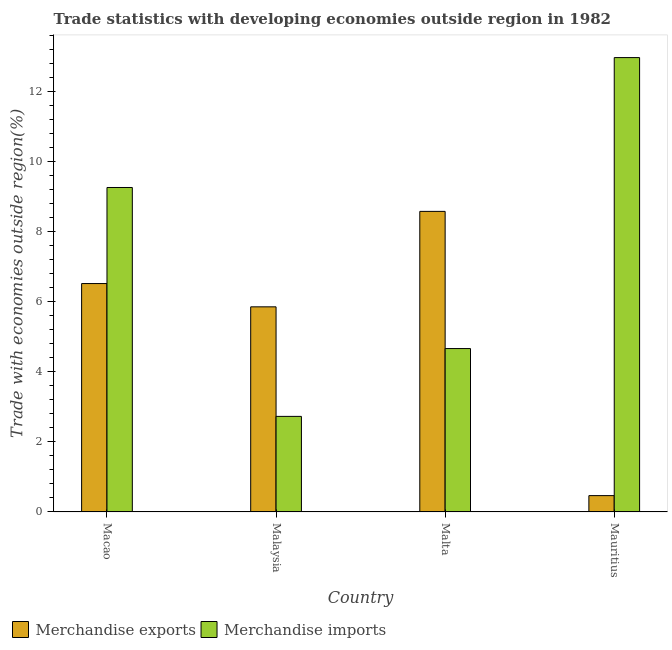Are the number of bars per tick equal to the number of legend labels?
Provide a short and direct response. Yes. Are the number of bars on each tick of the X-axis equal?
Provide a succinct answer. Yes. How many bars are there on the 1st tick from the left?
Provide a short and direct response. 2. What is the label of the 2nd group of bars from the left?
Keep it short and to the point. Malaysia. What is the merchandise exports in Malta?
Ensure brevity in your answer.  8.58. Across all countries, what is the maximum merchandise imports?
Your response must be concise. 12.97. Across all countries, what is the minimum merchandise exports?
Your answer should be compact. 0.47. In which country was the merchandise exports maximum?
Offer a terse response. Malta. In which country was the merchandise exports minimum?
Keep it short and to the point. Mauritius. What is the total merchandise exports in the graph?
Your response must be concise. 21.42. What is the difference between the merchandise imports in Malaysia and that in Mauritius?
Provide a succinct answer. -10.24. What is the difference between the merchandise imports in Macao and the merchandise exports in Malta?
Offer a terse response. 0.68. What is the average merchandise exports per country?
Provide a succinct answer. 5.35. What is the difference between the merchandise exports and merchandise imports in Macao?
Your answer should be very brief. -2.74. In how many countries, is the merchandise imports greater than 9.6 %?
Provide a short and direct response. 1. What is the ratio of the merchandise exports in Malta to that in Mauritius?
Your answer should be compact. 18.41. What is the difference between the highest and the second highest merchandise exports?
Your answer should be very brief. 2.06. What is the difference between the highest and the lowest merchandise exports?
Provide a succinct answer. 8.11. In how many countries, is the merchandise exports greater than the average merchandise exports taken over all countries?
Keep it short and to the point. 3. Is the sum of the merchandise exports in Macao and Malta greater than the maximum merchandise imports across all countries?
Offer a terse response. Yes. What does the 2nd bar from the left in Mauritius represents?
Give a very brief answer. Merchandise imports. Are all the bars in the graph horizontal?
Provide a succinct answer. No. What is the difference between two consecutive major ticks on the Y-axis?
Make the answer very short. 2. Does the graph contain grids?
Your answer should be very brief. No. How many legend labels are there?
Your answer should be very brief. 2. What is the title of the graph?
Your answer should be compact. Trade statistics with developing economies outside region in 1982. What is the label or title of the Y-axis?
Provide a succinct answer. Trade with economies outside region(%). What is the Trade with economies outside region(%) of Merchandise exports in Macao?
Ensure brevity in your answer.  6.52. What is the Trade with economies outside region(%) of Merchandise imports in Macao?
Provide a short and direct response. 9.26. What is the Trade with economies outside region(%) in Merchandise exports in Malaysia?
Make the answer very short. 5.85. What is the Trade with economies outside region(%) of Merchandise imports in Malaysia?
Offer a terse response. 2.73. What is the Trade with economies outside region(%) in Merchandise exports in Malta?
Give a very brief answer. 8.58. What is the Trade with economies outside region(%) of Merchandise imports in Malta?
Provide a succinct answer. 4.66. What is the Trade with economies outside region(%) of Merchandise exports in Mauritius?
Provide a succinct answer. 0.47. What is the Trade with economies outside region(%) in Merchandise imports in Mauritius?
Your answer should be very brief. 12.97. Across all countries, what is the maximum Trade with economies outside region(%) of Merchandise exports?
Offer a terse response. 8.58. Across all countries, what is the maximum Trade with economies outside region(%) in Merchandise imports?
Provide a short and direct response. 12.97. Across all countries, what is the minimum Trade with economies outside region(%) in Merchandise exports?
Your answer should be very brief. 0.47. Across all countries, what is the minimum Trade with economies outside region(%) in Merchandise imports?
Your response must be concise. 2.73. What is the total Trade with economies outside region(%) in Merchandise exports in the graph?
Give a very brief answer. 21.42. What is the total Trade with economies outside region(%) of Merchandise imports in the graph?
Provide a succinct answer. 29.62. What is the difference between the Trade with economies outside region(%) in Merchandise exports in Macao and that in Malaysia?
Your response must be concise. 0.66. What is the difference between the Trade with economies outside region(%) of Merchandise imports in Macao and that in Malaysia?
Your answer should be very brief. 6.53. What is the difference between the Trade with economies outside region(%) in Merchandise exports in Macao and that in Malta?
Keep it short and to the point. -2.06. What is the difference between the Trade with economies outside region(%) of Merchandise imports in Macao and that in Malta?
Provide a succinct answer. 4.6. What is the difference between the Trade with economies outside region(%) in Merchandise exports in Macao and that in Mauritius?
Keep it short and to the point. 6.05. What is the difference between the Trade with economies outside region(%) of Merchandise imports in Macao and that in Mauritius?
Provide a short and direct response. -3.71. What is the difference between the Trade with economies outside region(%) in Merchandise exports in Malaysia and that in Malta?
Provide a succinct answer. -2.72. What is the difference between the Trade with economies outside region(%) of Merchandise imports in Malaysia and that in Malta?
Give a very brief answer. -1.94. What is the difference between the Trade with economies outside region(%) in Merchandise exports in Malaysia and that in Mauritius?
Provide a short and direct response. 5.39. What is the difference between the Trade with economies outside region(%) in Merchandise imports in Malaysia and that in Mauritius?
Make the answer very short. -10.24. What is the difference between the Trade with economies outside region(%) in Merchandise exports in Malta and that in Mauritius?
Make the answer very short. 8.11. What is the difference between the Trade with economies outside region(%) in Merchandise imports in Malta and that in Mauritius?
Offer a very short reply. -8.3. What is the difference between the Trade with economies outside region(%) in Merchandise exports in Macao and the Trade with economies outside region(%) in Merchandise imports in Malaysia?
Make the answer very short. 3.79. What is the difference between the Trade with economies outside region(%) of Merchandise exports in Macao and the Trade with economies outside region(%) of Merchandise imports in Malta?
Offer a terse response. 1.86. What is the difference between the Trade with economies outside region(%) of Merchandise exports in Macao and the Trade with economies outside region(%) of Merchandise imports in Mauritius?
Give a very brief answer. -6.45. What is the difference between the Trade with economies outside region(%) in Merchandise exports in Malaysia and the Trade with economies outside region(%) in Merchandise imports in Malta?
Keep it short and to the point. 1.19. What is the difference between the Trade with economies outside region(%) in Merchandise exports in Malaysia and the Trade with economies outside region(%) in Merchandise imports in Mauritius?
Offer a very short reply. -7.11. What is the difference between the Trade with economies outside region(%) in Merchandise exports in Malta and the Trade with economies outside region(%) in Merchandise imports in Mauritius?
Offer a terse response. -4.39. What is the average Trade with economies outside region(%) in Merchandise exports per country?
Ensure brevity in your answer.  5.35. What is the average Trade with economies outside region(%) of Merchandise imports per country?
Offer a terse response. 7.4. What is the difference between the Trade with economies outside region(%) of Merchandise exports and Trade with economies outside region(%) of Merchandise imports in Macao?
Keep it short and to the point. -2.74. What is the difference between the Trade with economies outside region(%) of Merchandise exports and Trade with economies outside region(%) of Merchandise imports in Malaysia?
Keep it short and to the point. 3.13. What is the difference between the Trade with economies outside region(%) in Merchandise exports and Trade with economies outside region(%) in Merchandise imports in Malta?
Your answer should be very brief. 3.91. What is the difference between the Trade with economies outside region(%) of Merchandise exports and Trade with economies outside region(%) of Merchandise imports in Mauritius?
Provide a succinct answer. -12.5. What is the ratio of the Trade with economies outside region(%) of Merchandise exports in Macao to that in Malaysia?
Keep it short and to the point. 1.11. What is the ratio of the Trade with economies outside region(%) of Merchandise imports in Macao to that in Malaysia?
Make the answer very short. 3.4. What is the ratio of the Trade with economies outside region(%) of Merchandise exports in Macao to that in Malta?
Your answer should be very brief. 0.76. What is the ratio of the Trade with economies outside region(%) in Merchandise imports in Macao to that in Malta?
Offer a terse response. 1.99. What is the ratio of the Trade with economies outside region(%) in Merchandise exports in Macao to that in Mauritius?
Keep it short and to the point. 13.99. What is the ratio of the Trade with economies outside region(%) in Merchandise imports in Macao to that in Mauritius?
Your response must be concise. 0.71. What is the ratio of the Trade with economies outside region(%) of Merchandise exports in Malaysia to that in Malta?
Keep it short and to the point. 0.68. What is the ratio of the Trade with economies outside region(%) of Merchandise imports in Malaysia to that in Malta?
Provide a succinct answer. 0.58. What is the ratio of the Trade with economies outside region(%) in Merchandise exports in Malaysia to that in Mauritius?
Provide a succinct answer. 12.57. What is the ratio of the Trade with economies outside region(%) of Merchandise imports in Malaysia to that in Mauritius?
Offer a very short reply. 0.21. What is the ratio of the Trade with economies outside region(%) in Merchandise exports in Malta to that in Mauritius?
Your response must be concise. 18.41. What is the ratio of the Trade with economies outside region(%) of Merchandise imports in Malta to that in Mauritius?
Ensure brevity in your answer.  0.36. What is the difference between the highest and the second highest Trade with economies outside region(%) in Merchandise exports?
Your answer should be compact. 2.06. What is the difference between the highest and the second highest Trade with economies outside region(%) in Merchandise imports?
Give a very brief answer. 3.71. What is the difference between the highest and the lowest Trade with economies outside region(%) of Merchandise exports?
Make the answer very short. 8.11. What is the difference between the highest and the lowest Trade with economies outside region(%) in Merchandise imports?
Give a very brief answer. 10.24. 